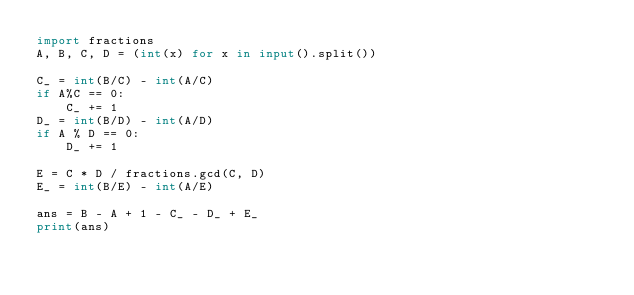<code> <loc_0><loc_0><loc_500><loc_500><_Python_>import fractions
A, B, C, D = (int(x) for x in input().split())

C_ = int(B/C) - int(A/C)
if A%C == 0:                                                                                                                                                                                                
    C_ += 1                                                                                                                                                                                                 
D_ = int(B/D) - int(A/D)
if A % D == 0:                                                                                                                                                                                              
    D_ += 1                                                                                                                                                                                                 

E = C * D / fractions.gcd(C, D)
E_ = int(B/E) - int(A/E)

ans = B - A + 1 - C_ - D_ + E_
print(ans)
</code> 